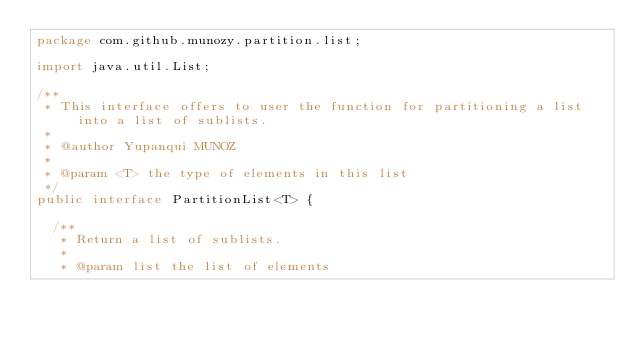Convert code to text. <code><loc_0><loc_0><loc_500><loc_500><_Java_>package com.github.munozy.partition.list;

import java.util.List;

/**
 * This interface offers to user the function for partitioning a list into a list of sublists. 
 * 
 * @author Yupanqui MUNOZ 
 *
 * @param <T> the type of elements in this list
 */
public interface PartitionList<T> {
	
	/**
	 * Return a list of sublists.
	 * 
	 * @param list the list of elements</code> 